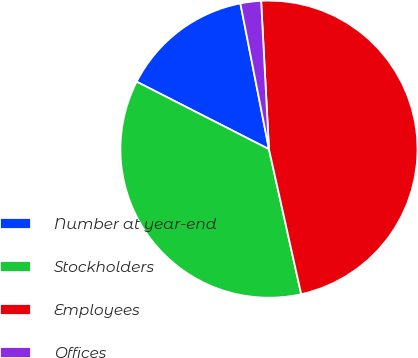Convert chart. <chart><loc_0><loc_0><loc_500><loc_500><pie_chart><fcel>Number at year-end<fcel>Stockholders<fcel>Employees<fcel>Offices<nl><fcel>14.41%<fcel>35.99%<fcel>47.36%<fcel>2.24%<nl></chart> 